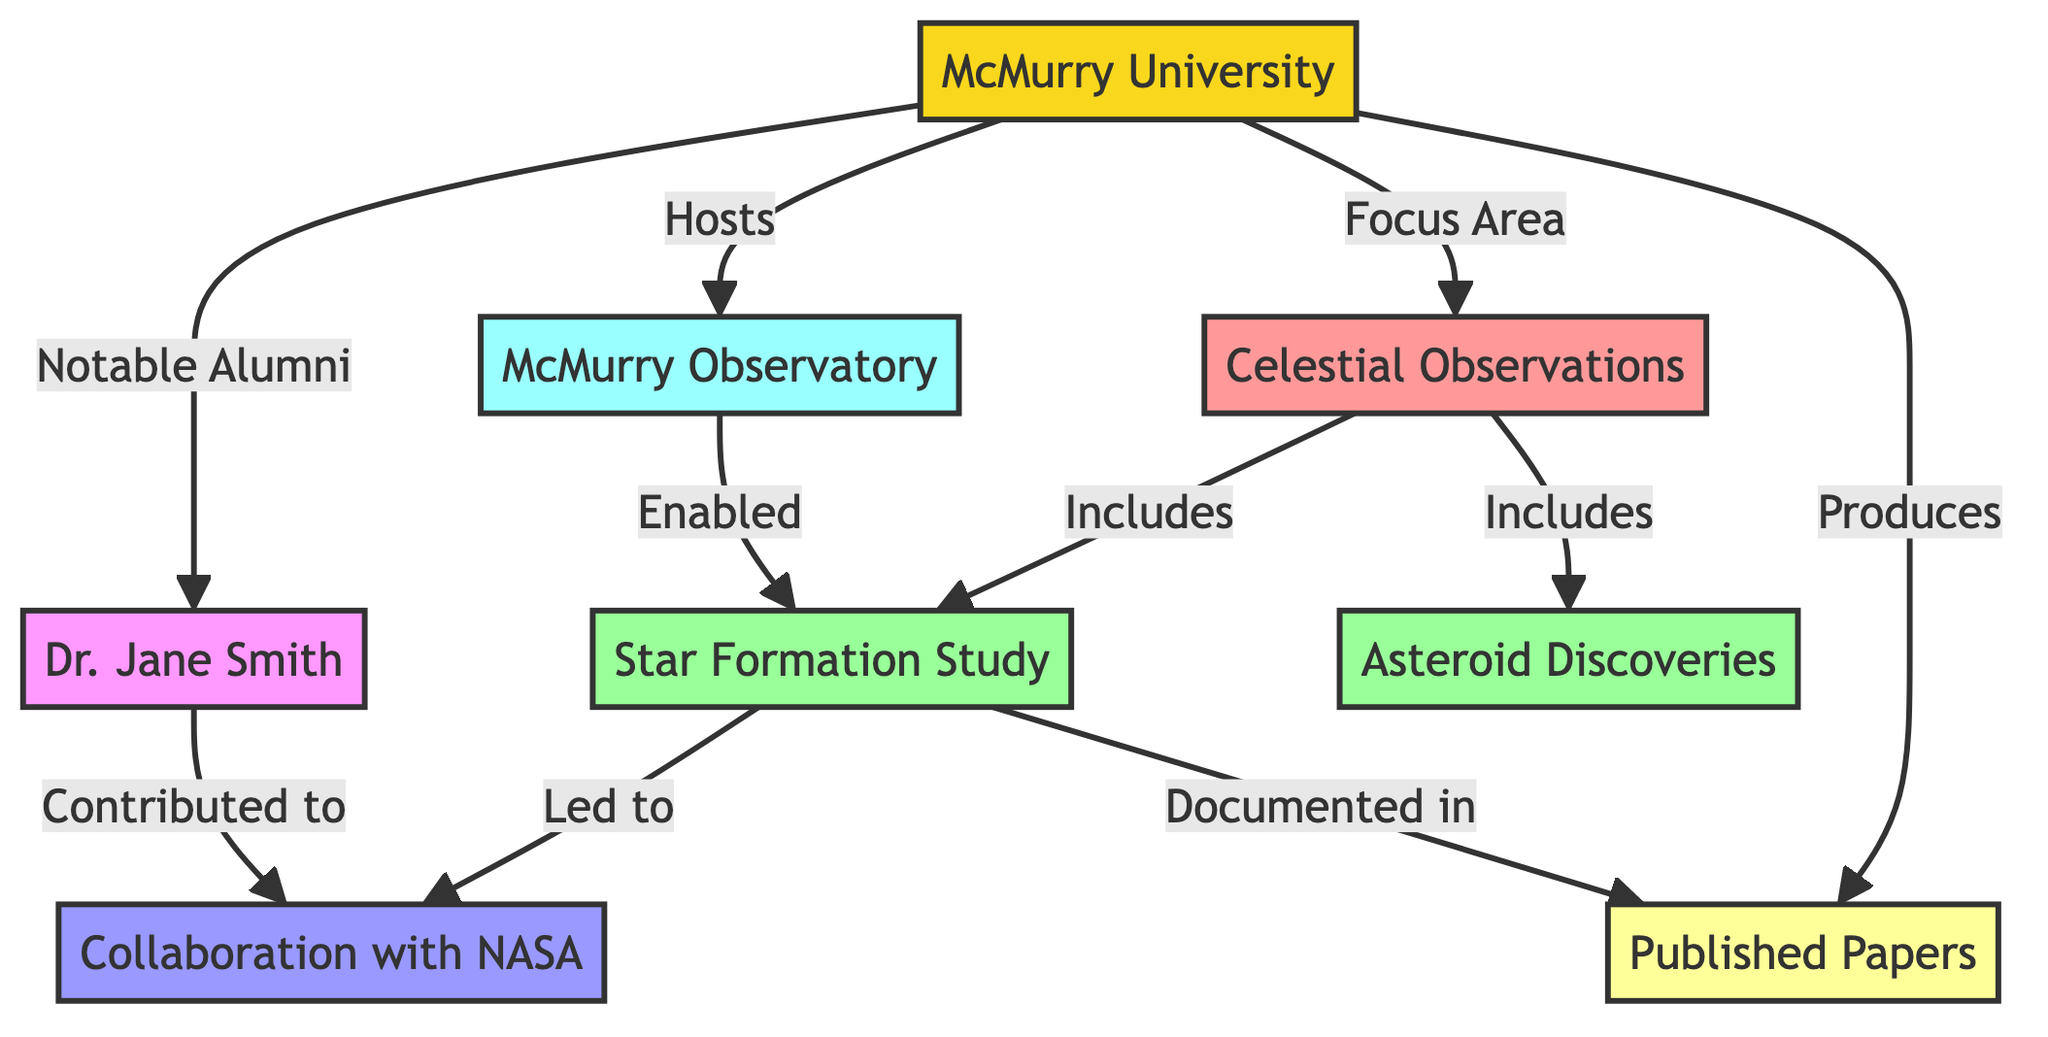What is the focus area of McMurry University in astronomy? The diagram directly links McMurry University to the category "Celestial Observations," indicating that this is the specific focus area of the institution within the field of astronomy.
Answer: Celestial Observations How many milestones are listed under celestial observations? By examining the nodes connected to "Celestial Observations," we find that there are two listed milestones: "Star Formation Study" and "Asteroid Discoveries." Therefore, the number of milestones is two.
Answer: 2 Who is the notable alumnus mentioned in the diagram? The diagram indicates that Dr. Jane Smith is a notable alumnus of McMurry University, explicitly connecting her to the university's achievements.
Answer: Dr. Jane Smith What is the relationship between "Star Formation Study" and "Collaboration with NASA"? The flowchart shows a direct link from "Star Formation Study" to "Collaboration with NASA," signifying that the star formation research led to collaboration efforts with NASA.
Answer: Led to Which facility does McMurry University host for its astronomy research? The diagram identifies "McMurry Observatory" as the specific facility that McMurry University hosts, clearly linking it as part of their astronomy research infrastructure.
Answer: McMurry Observatory What type of achievements are highlighted in the diagram associated with Dr. Jane Smith? Dr. Jane Smith is connected to "Collaboration with NASA," indicating that her contributions relate specifically to achievements in that area, showcasing her involvement in notable accomplishments in astronomy through collaboration.
Answer: Collaboration with NASA Which output is produced by McMurry University related to astronomy? The diagram explicitly states that "Published Papers" are an output produced by McMurry University, connecting the university's research endeavors to documented findings in the form of publications.
Answer: Published Papers How does the "McMurry Observatory" enable the "Star Formation Study"? The diagram indicates that "McMurry Observatory" has a direct link to "Star Formation Study," suggesting that the observatory provides the necessary resources or environment that allows for the study of star formation to occur.
Answer: Enabled What information is documented in the output of "Published Papers"? The diagram shows that the findings from the "Star Formation Study" are documented in "Published Papers," illustrating how the research output is reflected in academic publications.
Answer: Documented in 